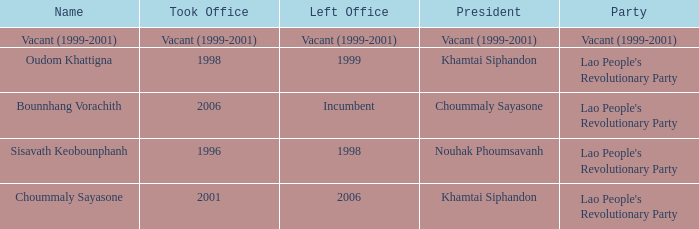What is Left Office, when Took Office is 2006? Incumbent. 